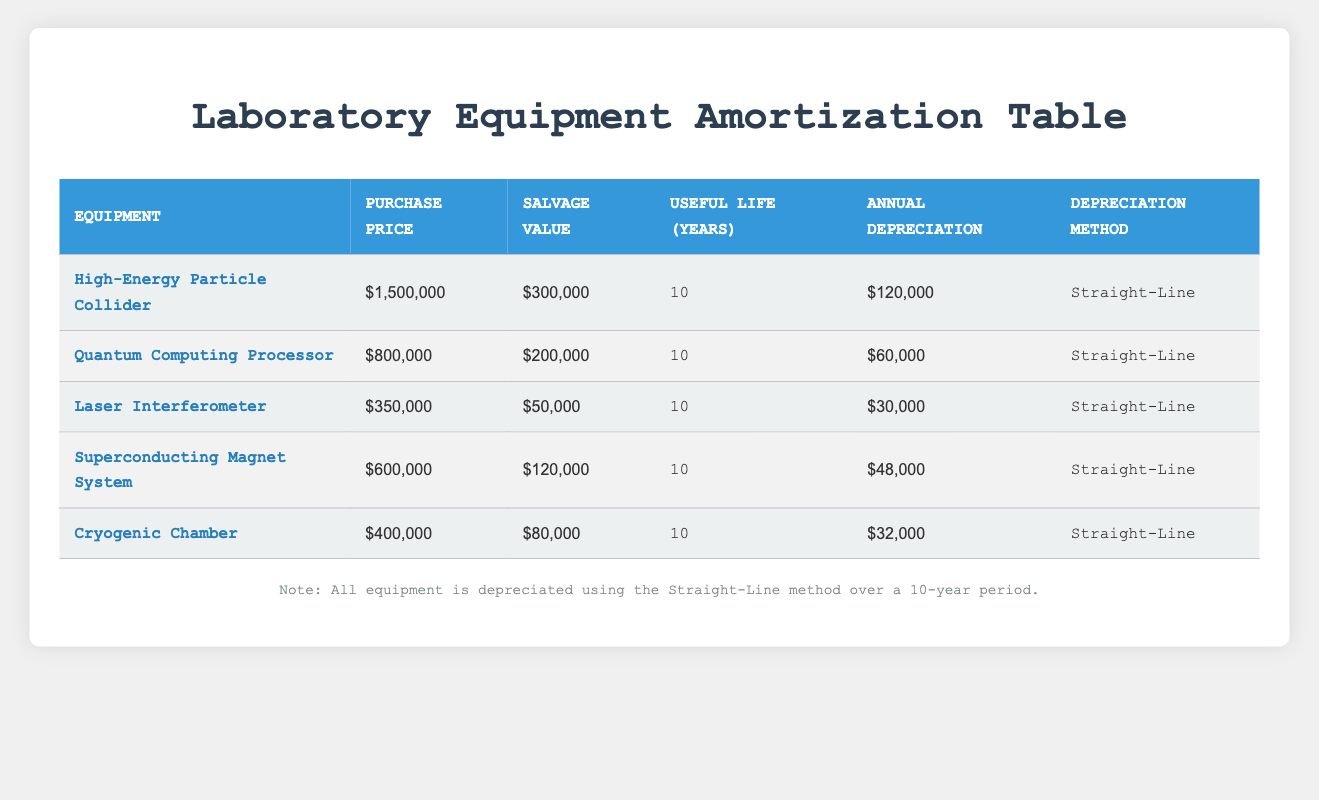What is the purchase price of the High-Energy Particle Collider? The purchase price for the High-Energy Particle Collider is directly listed in the table under the "Purchase Price" column.
Answer: 1,500,000 How much is the annual depreciation for the Quantum Computing Processor? The annual depreciation for the Quantum Computing Processor can be found in the table under the "Annual Depreciation" column.
Answer: 60,000 Is the depreciation method for the Cryogenic Chamber different from that of the Laser Interferometer? Both the Cryogenic Chamber and the Laser Interferometer use the Straight-Line depreciation method, as stated in the respective rows in the "Depreciation Method" column.
Answer: No What is the total annual depreciation for all the equipment listed? To find the total annual depreciation, sum the annual depreciation values for all the equipment: 120,000 + 60,000 + 30,000 + 48,000 + 32,000 = 290,000.
Answer: 290,000 What is the difference in purchase price between the Superconducting Magnet System and the Cryogenic Chamber? The purchase price of the Superconducting Magnet System is 600,000 and that of the Cryogenic Chamber is 400,000. The difference is 600,000 - 400,000 = 200,000.
Answer: 200,000 What is the average annual depreciation for all the pieces of equipment? To calculate the average, first sum all annual depreciations: 120,000 + 60,000 + 30,000 + 48,000 + 32,000 = 290,000. Then divide by the number of equipment items (5): 290,000 / 5 = 58,000.
Answer: 58,000 Is the salvage value of the High-Energy Particle Collider greater than that of the Quantum Computing Processor? The salvage value of the High-Energy Particle Collider is 300,000, and the salvage value for the Quantum Computing Processor is 200,000. Since 300,000 is greater than 200,000, the statement is true.
Answer: Yes Which equipment has the highest annual depreciation? By comparing the annual depreciation amounts in the table, the High-Energy Particle Collider has the highest annual depreciation at 120,000.
Answer: High-Energy Particle Collider What can you say about the equipment with the lowest salvage value? The Laser Interferometer has the lowest salvage value of 50,000, which indicates its likely lesser worth or utility at the end of its useful life compared to the others.
Answer: Laser Interferometer 